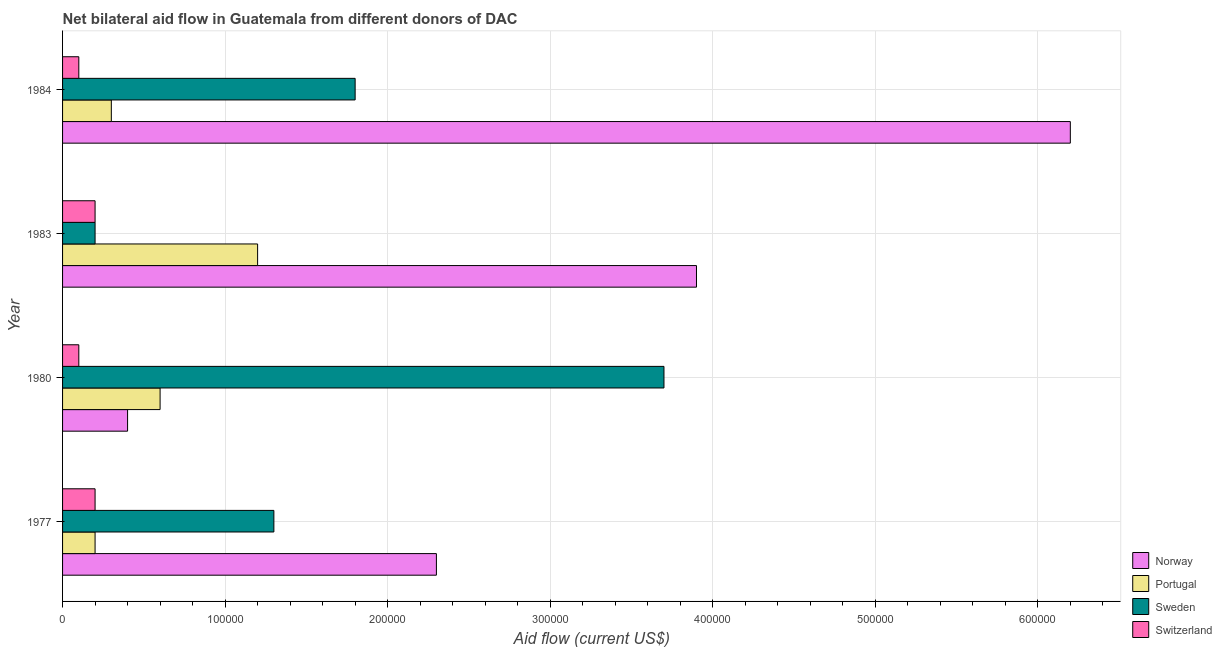How many different coloured bars are there?
Ensure brevity in your answer.  4. How many groups of bars are there?
Provide a succinct answer. 4. Are the number of bars per tick equal to the number of legend labels?
Your answer should be compact. Yes. What is the label of the 1st group of bars from the top?
Keep it short and to the point. 1984. In how many cases, is the number of bars for a given year not equal to the number of legend labels?
Your answer should be very brief. 0. What is the amount of aid given by norway in 1977?
Offer a very short reply. 2.30e+05. Across all years, what is the maximum amount of aid given by switzerland?
Provide a succinct answer. 2.00e+04. Across all years, what is the minimum amount of aid given by norway?
Keep it short and to the point. 4.00e+04. In which year was the amount of aid given by sweden minimum?
Keep it short and to the point. 1983. What is the total amount of aid given by switzerland in the graph?
Provide a short and direct response. 6.00e+04. What is the difference between the amount of aid given by sweden in 1977 and that in 1983?
Give a very brief answer. 1.10e+05. What is the difference between the amount of aid given by switzerland in 1977 and the amount of aid given by portugal in 1984?
Your answer should be very brief. -10000. What is the average amount of aid given by portugal per year?
Your answer should be very brief. 5.75e+04. In the year 1977, what is the difference between the amount of aid given by sweden and amount of aid given by switzerland?
Make the answer very short. 1.10e+05. In how many years, is the amount of aid given by sweden greater than 540000 US$?
Provide a succinct answer. 0. What is the ratio of the amount of aid given by portugal in 1977 to that in 1983?
Your response must be concise. 0.17. Is the amount of aid given by norway in 1977 less than that in 1984?
Make the answer very short. Yes. What is the difference between the highest and the second highest amount of aid given by portugal?
Make the answer very short. 6.00e+04. What is the difference between the highest and the lowest amount of aid given by sweden?
Your answer should be compact. 3.50e+05. What does the 4th bar from the top in 1983 represents?
Ensure brevity in your answer.  Norway. What does the 4th bar from the bottom in 1980 represents?
Keep it short and to the point. Switzerland. How many bars are there?
Keep it short and to the point. 16. Are the values on the major ticks of X-axis written in scientific E-notation?
Make the answer very short. No. Does the graph contain any zero values?
Ensure brevity in your answer.  No. Does the graph contain grids?
Offer a terse response. Yes. How many legend labels are there?
Offer a terse response. 4. What is the title of the graph?
Your answer should be compact. Net bilateral aid flow in Guatemala from different donors of DAC. What is the label or title of the Y-axis?
Give a very brief answer. Year. What is the Aid flow (current US$) of Sweden in 1977?
Ensure brevity in your answer.  1.30e+05. What is the Aid flow (current US$) in Switzerland in 1977?
Give a very brief answer. 2.00e+04. What is the Aid flow (current US$) in Norway in 1980?
Your answer should be compact. 4.00e+04. What is the Aid flow (current US$) of Switzerland in 1980?
Offer a very short reply. 10000. What is the Aid flow (current US$) in Norway in 1983?
Your answer should be very brief. 3.90e+05. What is the Aid flow (current US$) in Portugal in 1983?
Provide a succinct answer. 1.20e+05. What is the Aid flow (current US$) of Switzerland in 1983?
Make the answer very short. 2.00e+04. What is the Aid flow (current US$) in Norway in 1984?
Your response must be concise. 6.20e+05. What is the Aid flow (current US$) of Portugal in 1984?
Keep it short and to the point. 3.00e+04. Across all years, what is the maximum Aid flow (current US$) of Norway?
Keep it short and to the point. 6.20e+05. Across all years, what is the maximum Aid flow (current US$) in Portugal?
Make the answer very short. 1.20e+05. Across all years, what is the maximum Aid flow (current US$) in Sweden?
Provide a short and direct response. 3.70e+05. Across all years, what is the maximum Aid flow (current US$) in Switzerland?
Your answer should be very brief. 2.00e+04. Across all years, what is the minimum Aid flow (current US$) of Norway?
Offer a terse response. 4.00e+04. Across all years, what is the minimum Aid flow (current US$) in Sweden?
Provide a succinct answer. 2.00e+04. What is the total Aid flow (current US$) of Norway in the graph?
Keep it short and to the point. 1.28e+06. What is the total Aid flow (current US$) of Portugal in the graph?
Provide a short and direct response. 2.30e+05. What is the total Aid flow (current US$) in Sweden in the graph?
Offer a very short reply. 7.00e+05. What is the total Aid flow (current US$) in Switzerland in the graph?
Provide a succinct answer. 6.00e+04. What is the difference between the Aid flow (current US$) of Sweden in 1977 and that in 1980?
Offer a terse response. -2.40e+05. What is the difference between the Aid flow (current US$) in Switzerland in 1977 and that in 1980?
Your response must be concise. 10000. What is the difference between the Aid flow (current US$) of Norway in 1977 and that in 1984?
Provide a short and direct response. -3.90e+05. What is the difference between the Aid flow (current US$) of Sweden in 1977 and that in 1984?
Provide a short and direct response. -5.00e+04. What is the difference between the Aid flow (current US$) of Switzerland in 1977 and that in 1984?
Offer a terse response. 10000. What is the difference between the Aid flow (current US$) of Norway in 1980 and that in 1983?
Provide a short and direct response. -3.50e+05. What is the difference between the Aid flow (current US$) of Sweden in 1980 and that in 1983?
Ensure brevity in your answer.  3.50e+05. What is the difference between the Aid flow (current US$) of Norway in 1980 and that in 1984?
Ensure brevity in your answer.  -5.80e+05. What is the difference between the Aid flow (current US$) of Portugal in 1980 and that in 1984?
Offer a terse response. 3.00e+04. What is the difference between the Aid flow (current US$) in Sweden in 1980 and that in 1984?
Provide a short and direct response. 1.90e+05. What is the difference between the Aid flow (current US$) of Switzerland in 1980 and that in 1984?
Your answer should be compact. 0. What is the difference between the Aid flow (current US$) of Norway in 1977 and the Aid flow (current US$) of Portugal in 1980?
Your response must be concise. 1.70e+05. What is the difference between the Aid flow (current US$) of Norway in 1977 and the Aid flow (current US$) of Sweden in 1980?
Give a very brief answer. -1.40e+05. What is the difference between the Aid flow (current US$) in Norway in 1977 and the Aid flow (current US$) in Switzerland in 1980?
Your answer should be compact. 2.20e+05. What is the difference between the Aid flow (current US$) in Portugal in 1977 and the Aid flow (current US$) in Sweden in 1980?
Provide a short and direct response. -3.50e+05. What is the difference between the Aid flow (current US$) in Portugal in 1977 and the Aid flow (current US$) in Switzerland in 1980?
Provide a succinct answer. 10000. What is the difference between the Aid flow (current US$) of Sweden in 1977 and the Aid flow (current US$) of Switzerland in 1980?
Ensure brevity in your answer.  1.20e+05. What is the difference between the Aid flow (current US$) of Norway in 1977 and the Aid flow (current US$) of Portugal in 1983?
Provide a succinct answer. 1.10e+05. What is the difference between the Aid flow (current US$) of Sweden in 1977 and the Aid flow (current US$) of Switzerland in 1983?
Your answer should be compact. 1.10e+05. What is the difference between the Aid flow (current US$) in Norway in 1977 and the Aid flow (current US$) in Portugal in 1984?
Give a very brief answer. 2.00e+05. What is the difference between the Aid flow (current US$) in Portugal in 1977 and the Aid flow (current US$) in Sweden in 1984?
Your answer should be compact. -1.60e+05. What is the difference between the Aid flow (current US$) in Portugal in 1977 and the Aid flow (current US$) in Switzerland in 1984?
Your response must be concise. 10000. What is the difference between the Aid flow (current US$) in Sweden in 1977 and the Aid flow (current US$) in Switzerland in 1984?
Provide a short and direct response. 1.20e+05. What is the difference between the Aid flow (current US$) of Norway in 1980 and the Aid flow (current US$) of Portugal in 1984?
Keep it short and to the point. 10000. What is the difference between the Aid flow (current US$) in Norway in 1980 and the Aid flow (current US$) in Switzerland in 1984?
Your response must be concise. 3.00e+04. What is the difference between the Aid flow (current US$) of Portugal in 1980 and the Aid flow (current US$) of Sweden in 1984?
Provide a succinct answer. -1.20e+05. What is the difference between the Aid flow (current US$) in Portugal in 1980 and the Aid flow (current US$) in Switzerland in 1984?
Give a very brief answer. 5.00e+04. What is the difference between the Aid flow (current US$) in Sweden in 1980 and the Aid flow (current US$) in Switzerland in 1984?
Offer a very short reply. 3.60e+05. What is the difference between the Aid flow (current US$) of Norway in 1983 and the Aid flow (current US$) of Sweden in 1984?
Make the answer very short. 2.10e+05. What is the difference between the Aid flow (current US$) of Norway in 1983 and the Aid flow (current US$) of Switzerland in 1984?
Your response must be concise. 3.80e+05. What is the difference between the Aid flow (current US$) in Portugal in 1983 and the Aid flow (current US$) in Sweden in 1984?
Your answer should be compact. -6.00e+04. What is the difference between the Aid flow (current US$) in Portugal in 1983 and the Aid flow (current US$) in Switzerland in 1984?
Your response must be concise. 1.10e+05. What is the average Aid flow (current US$) of Portugal per year?
Offer a very short reply. 5.75e+04. What is the average Aid flow (current US$) of Sweden per year?
Offer a very short reply. 1.75e+05. What is the average Aid flow (current US$) in Switzerland per year?
Your answer should be very brief. 1.50e+04. In the year 1977, what is the difference between the Aid flow (current US$) of Norway and Aid flow (current US$) of Sweden?
Keep it short and to the point. 1.00e+05. In the year 1977, what is the difference between the Aid flow (current US$) in Portugal and Aid flow (current US$) in Sweden?
Offer a terse response. -1.10e+05. In the year 1980, what is the difference between the Aid flow (current US$) of Norway and Aid flow (current US$) of Sweden?
Provide a succinct answer. -3.30e+05. In the year 1980, what is the difference between the Aid flow (current US$) in Norway and Aid flow (current US$) in Switzerland?
Your response must be concise. 3.00e+04. In the year 1980, what is the difference between the Aid flow (current US$) in Portugal and Aid flow (current US$) in Sweden?
Your answer should be very brief. -3.10e+05. In the year 1980, what is the difference between the Aid flow (current US$) of Sweden and Aid flow (current US$) of Switzerland?
Offer a very short reply. 3.60e+05. In the year 1983, what is the difference between the Aid flow (current US$) in Norway and Aid flow (current US$) in Portugal?
Your answer should be very brief. 2.70e+05. In the year 1983, what is the difference between the Aid flow (current US$) of Sweden and Aid flow (current US$) of Switzerland?
Provide a short and direct response. 0. In the year 1984, what is the difference between the Aid flow (current US$) in Norway and Aid flow (current US$) in Portugal?
Ensure brevity in your answer.  5.90e+05. In the year 1984, what is the difference between the Aid flow (current US$) of Norway and Aid flow (current US$) of Sweden?
Your answer should be very brief. 4.40e+05. In the year 1984, what is the difference between the Aid flow (current US$) in Portugal and Aid flow (current US$) in Sweden?
Make the answer very short. -1.50e+05. In the year 1984, what is the difference between the Aid flow (current US$) in Portugal and Aid flow (current US$) in Switzerland?
Offer a very short reply. 2.00e+04. What is the ratio of the Aid flow (current US$) in Norway in 1977 to that in 1980?
Offer a terse response. 5.75. What is the ratio of the Aid flow (current US$) in Portugal in 1977 to that in 1980?
Provide a succinct answer. 0.33. What is the ratio of the Aid flow (current US$) in Sweden in 1977 to that in 1980?
Make the answer very short. 0.35. What is the ratio of the Aid flow (current US$) of Switzerland in 1977 to that in 1980?
Keep it short and to the point. 2. What is the ratio of the Aid flow (current US$) of Norway in 1977 to that in 1983?
Ensure brevity in your answer.  0.59. What is the ratio of the Aid flow (current US$) of Portugal in 1977 to that in 1983?
Offer a terse response. 0.17. What is the ratio of the Aid flow (current US$) of Switzerland in 1977 to that in 1983?
Offer a terse response. 1. What is the ratio of the Aid flow (current US$) in Norway in 1977 to that in 1984?
Make the answer very short. 0.37. What is the ratio of the Aid flow (current US$) in Sweden in 1977 to that in 1984?
Offer a terse response. 0.72. What is the ratio of the Aid flow (current US$) in Switzerland in 1977 to that in 1984?
Your answer should be very brief. 2. What is the ratio of the Aid flow (current US$) in Norway in 1980 to that in 1983?
Your response must be concise. 0.1. What is the ratio of the Aid flow (current US$) in Portugal in 1980 to that in 1983?
Provide a short and direct response. 0.5. What is the ratio of the Aid flow (current US$) in Switzerland in 1980 to that in 1983?
Your response must be concise. 0.5. What is the ratio of the Aid flow (current US$) of Norway in 1980 to that in 1984?
Make the answer very short. 0.06. What is the ratio of the Aid flow (current US$) in Portugal in 1980 to that in 1984?
Your answer should be very brief. 2. What is the ratio of the Aid flow (current US$) in Sweden in 1980 to that in 1984?
Provide a succinct answer. 2.06. What is the ratio of the Aid flow (current US$) of Norway in 1983 to that in 1984?
Provide a succinct answer. 0.63. What is the ratio of the Aid flow (current US$) of Sweden in 1983 to that in 1984?
Offer a terse response. 0.11. What is the ratio of the Aid flow (current US$) of Switzerland in 1983 to that in 1984?
Keep it short and to the point. 2. What is the difference between the highest and the second highest Aid flow (current US$) of Portugal?
Offer a very short reply. 6.00e+04. What is the difference between the highest and the second highest Aid flow (current US$) of Sweden?
Your answer should be very brief. 1.90e+05. What is the difference between the highest and the second highest Aid flow (current US$) in Switzerland?
Your answer should be very brief. 0. What is the difference between the highest and the lowest Aid flow (current US$) of Norway?
Your answer should be compact. 5.80e+05. What is the difference between the highest and the lowest Aid flow (current US$) of Sweden?
Offer a terse response. 3.50e+05. What is the difference between the highest and the lowest Aid flow (current US$) of Switzerland?
Make the answer very short. 10000. 